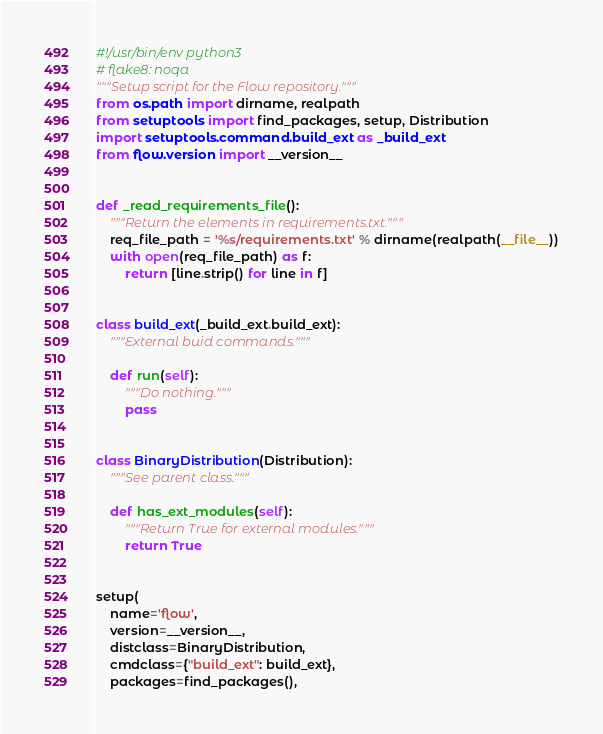Convert code to text. <code><loc_0><loc_0><loc_500><loc_500><_Python_>#!/usr/bin/env python3
# flake8: noqa
"""Setup script for the Flow repository."""
from os.path import dirname, realpath
from setuptools import find_packages, setup, Distribution
import setuptools.command.build_ext as _build_ext
from flow.version import __version__


def _read_requirements_file():
    """Return the elements in requirements.txt."""
    req_file_path = '%s/requirements.txt' % dirname(realpath(__file__))
    with open(req_file_path) as f:
        return [line.strip() for line in f]


class build_ext(_build_ext.build_ext):
    """External buid commands."""

    def run(self):
        """Do nothing."""
        pass


class BinaryDistribution(Distribution):
    """See parent class."""

    def has_ext_modules(self):
        """Return True for external modules."""
        return True


setup(
    name='flow',
    version=__version__,
    distclass=BinaryDistribution,
    cmdclass={"build_ext": build_ext},
    packages=find_packages(),</code> 